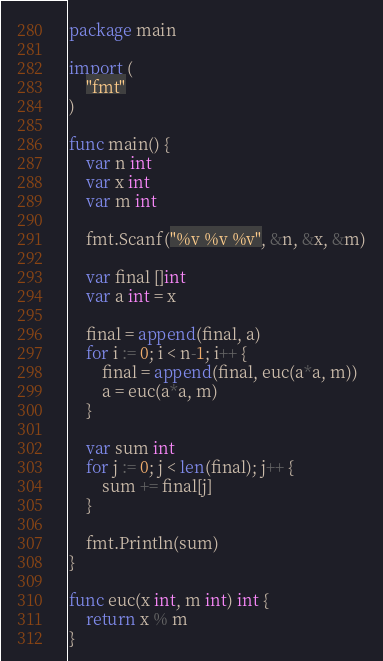Convert code to text. <code><loc_0><loc_0><loc_500><loc_500><_Go_>package main

import (
	"fmt"
)

func main() {
	var n int
	var x int
	var m int

	fmt.Scanf("%v %v %v", &n, &x, &m)

	var final []int
	var a int = x

	final = append(final, a)
	for i := 0; i < n-1; i++ {
		final = append(final, euc(a*a, m))
		a = euc(a*a, m)
	}

	var sum int
	for j := 0; j < len(final); j++ {
		sum += final[j]
	}

	fmt.Println(sum)
}

func euc(x int, m int) int {
	return x % m
}</code> 